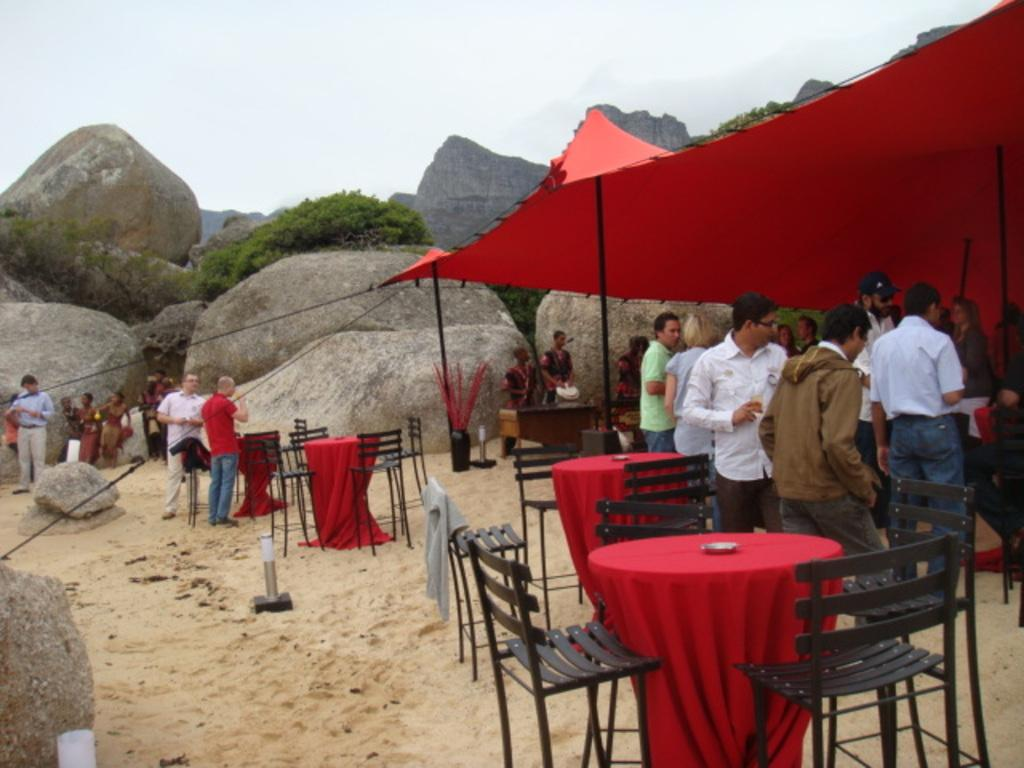How many people are in the image? There is a group of people in the image, but the exact number is not specified. What are the people in the image doing? The people are standing in the image. What is present in the image besides the group of people? There is a table in the image. What can be seen in the background of the image? In the background of the image, there is a rock, trees, and the sky. How many trees are visible in the background of the image? There is at least one tree visible in the background of the image. What type of coil is being used by the people in the image? There is no coil present in the image; the people are simply standing. What page of the book are the people reading in the image? There is no book present in the image, so it is not possible to determine which page they might be reading. 